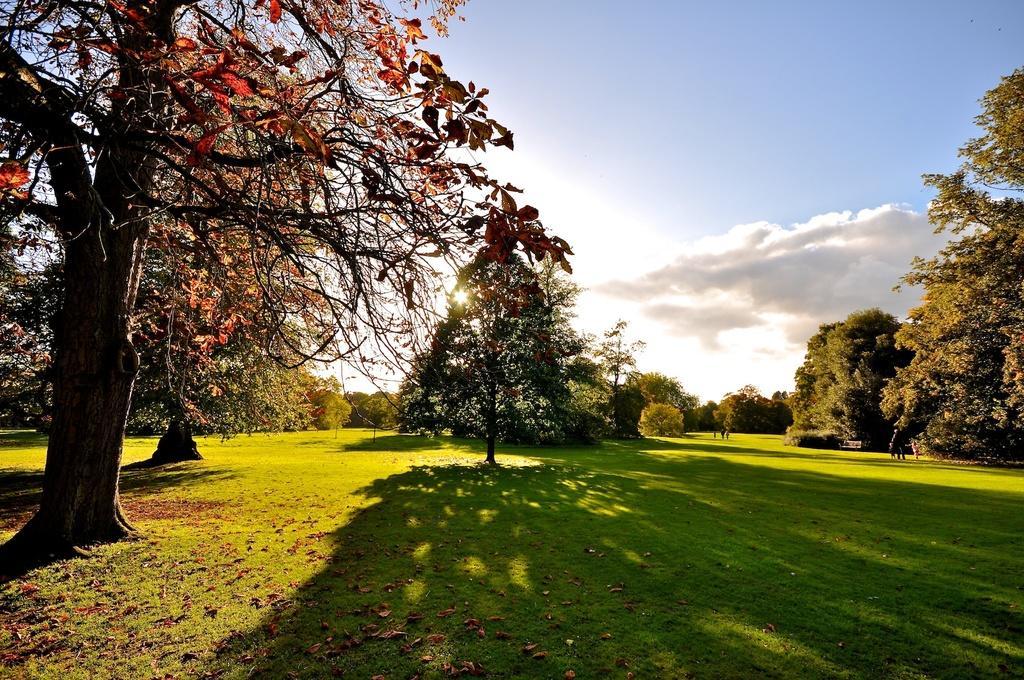Please provide a concise description of this image. This image is clicked at an open ground. There is green grass on the ground. There are trees in the image. At the top there is the sky. 